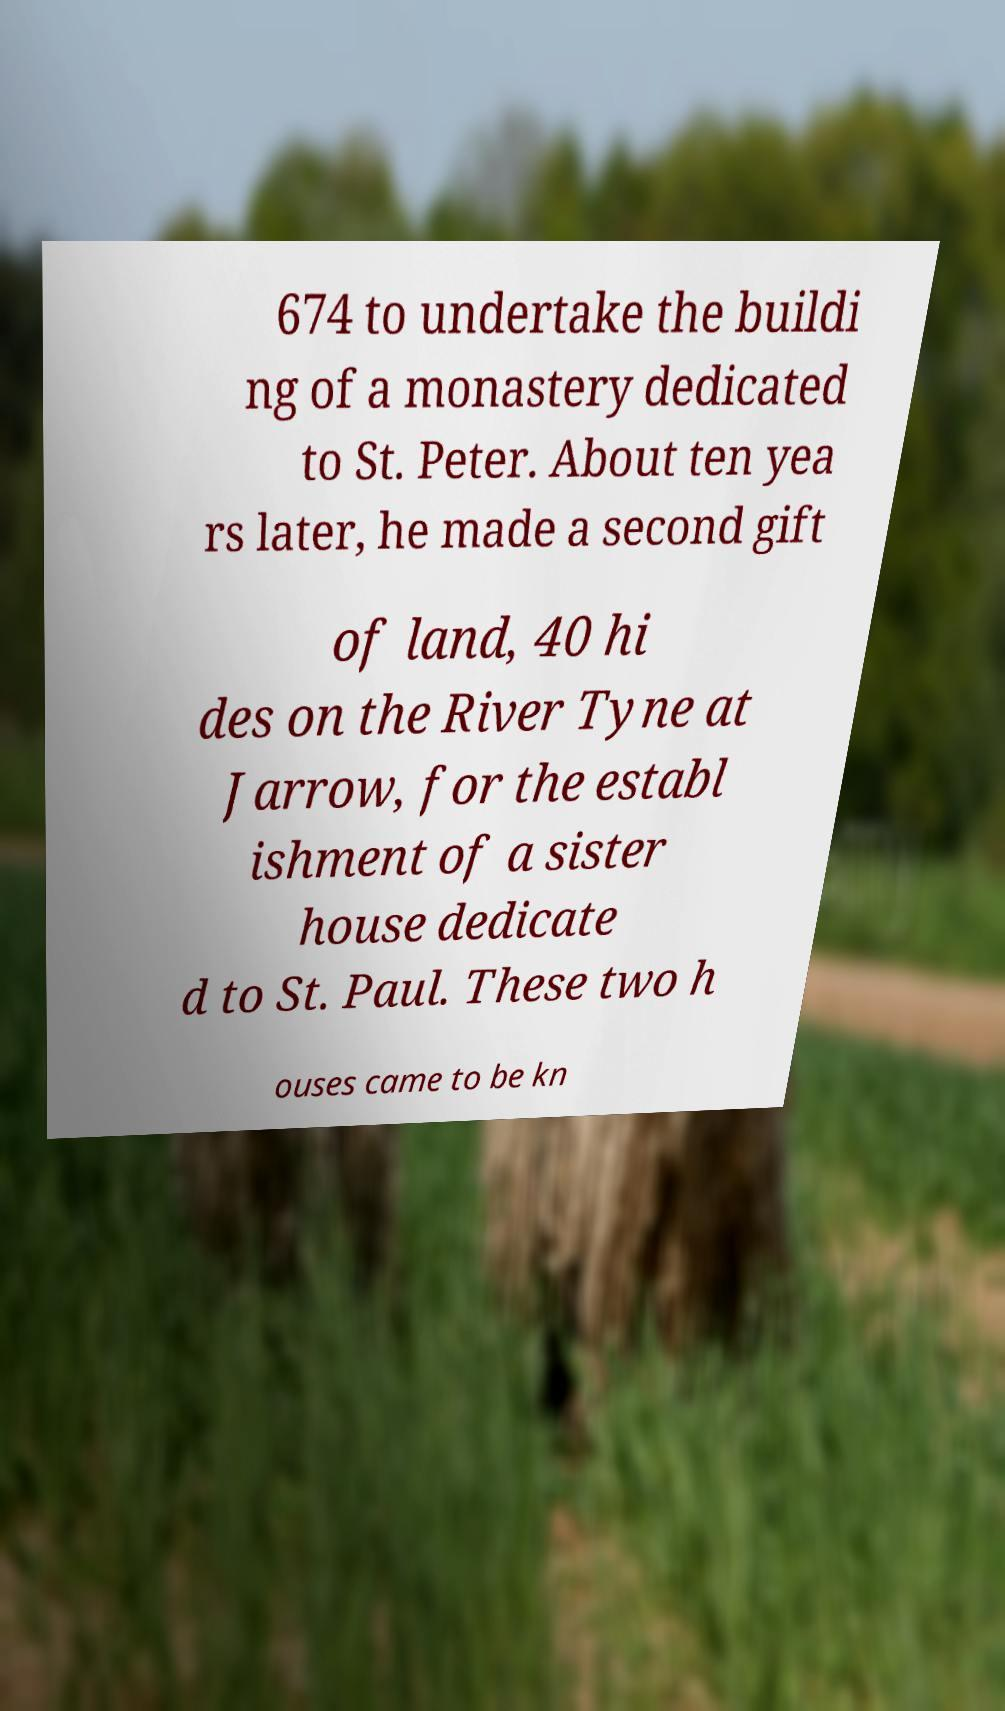Can you read and provide the text displayed in the image?This photo seems to have some interesting text. Can you extract and type it out for me? 674 to undertake the buildi ng of a monastery dedicated to St. Peter. About ten yea rs later, he made a second gift of land, 40 hi des on the River Tyne at Jarrow, for the establ ishment of a sister house dedicate d to St. Paul. These two h ouses came to be kn 